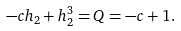<formula> <loc_0><loc_0><loc_500><loc_500>- c h _ { 2 } + h _ { 2 } ^ { 3 } = Q = - c + 1 .</formula> 